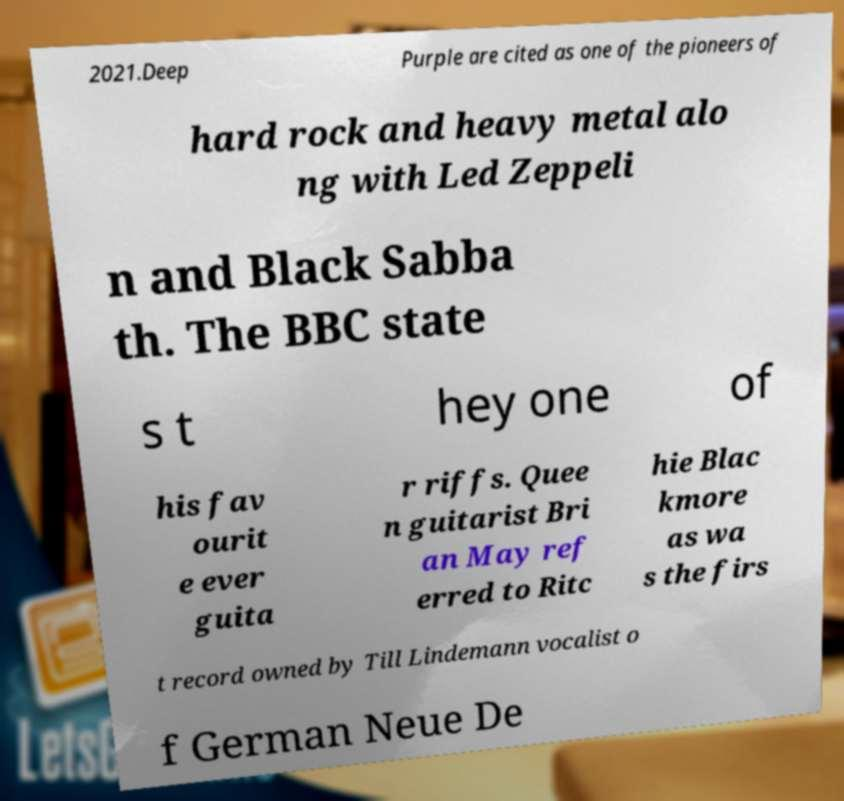For documentation purposes, I need the text within this image transcribed. Could you provide that? 2021.Deep Purple are cited as one of the pioneers of hard rock and heavy metal alo ng with Led Zeppeli n and Black Sabba th. The BBC state s t hey one of his fav ourit e ever guita r riffs. Quee n guitarist Bri an May ref erred to Ritc hie Blac kmore as wa s the firs t record owned by Till Lindemann vocalist o f German Neue De 